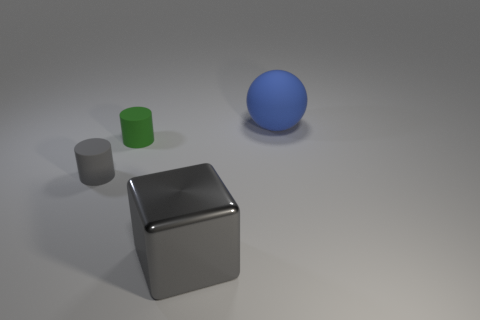What are the colors of the different objects in the image? In the image, we see a large gray cube, a smaller gray cube, a green cylinder, and a blue sphere. 